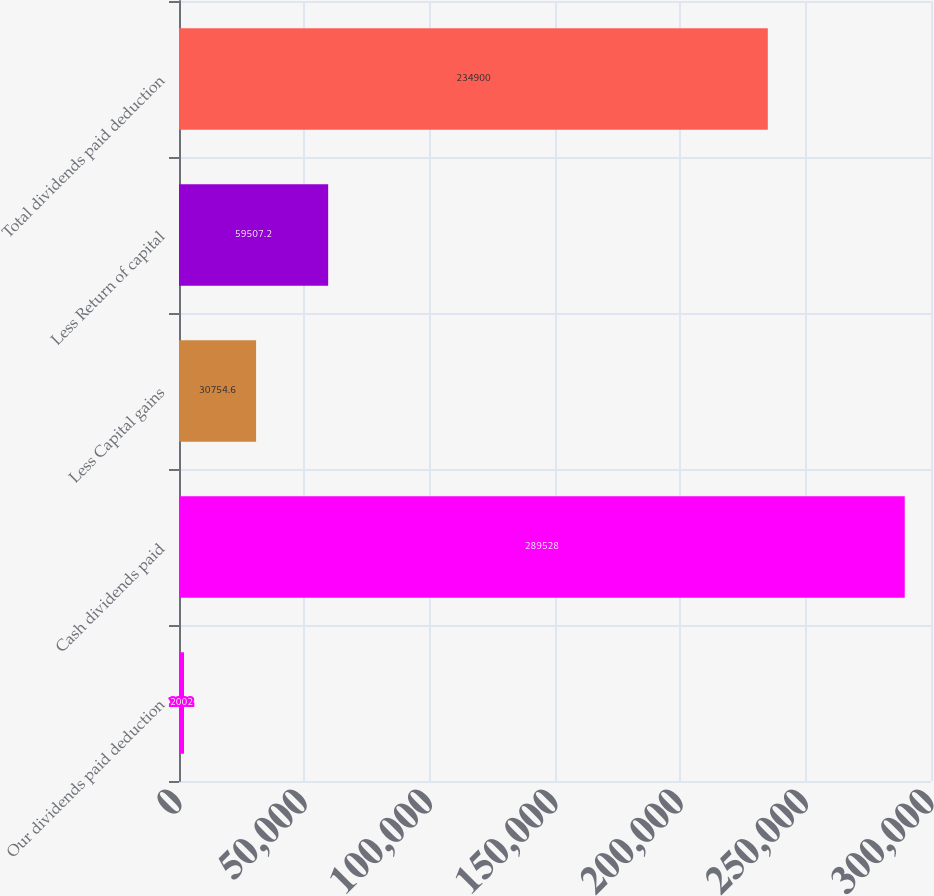<chart> <loc_0><loc_0><loc_500><loc_500><bar_chart><fcel>Our dividends paid deduction<fcel>Cash dividends paid<fcel>Less Capital gains<fcel>Less Return of capital<fcel>Total dividends paid deduction<nl><fcel>2002<fcel>289528<fcel>30754.6<fcel>59507.2<fcel>234900<nl></chart> 